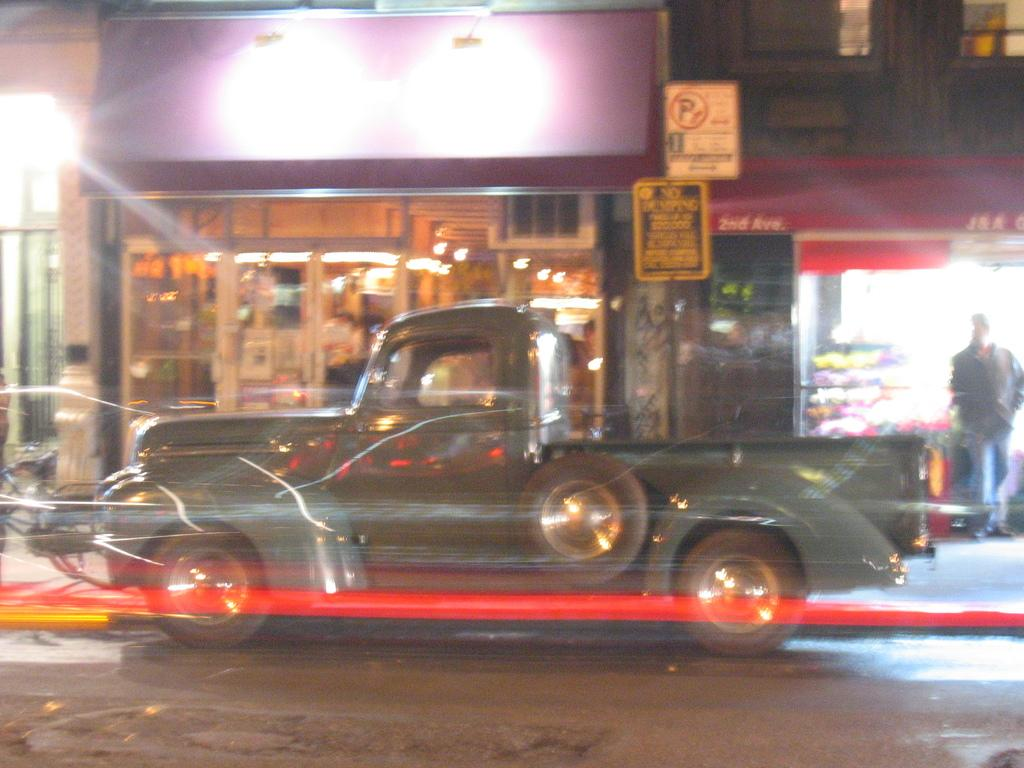What is the main subject of the image? There is a vehicle in the image. What can be seen besides the vehicle? There are name boards, lights, a person, buildings, other objects, and a road visible in the image. What might the name boards be used for? The name boards might be used for identification or direction. Can you describe the lighting in the image? There are lights visible in the image, but their purpose or intensity cannot be determined from the image alone. What type of milk is being transported by the vehicle in the image? There is no indication of any milk or transportation of milk in the image. 